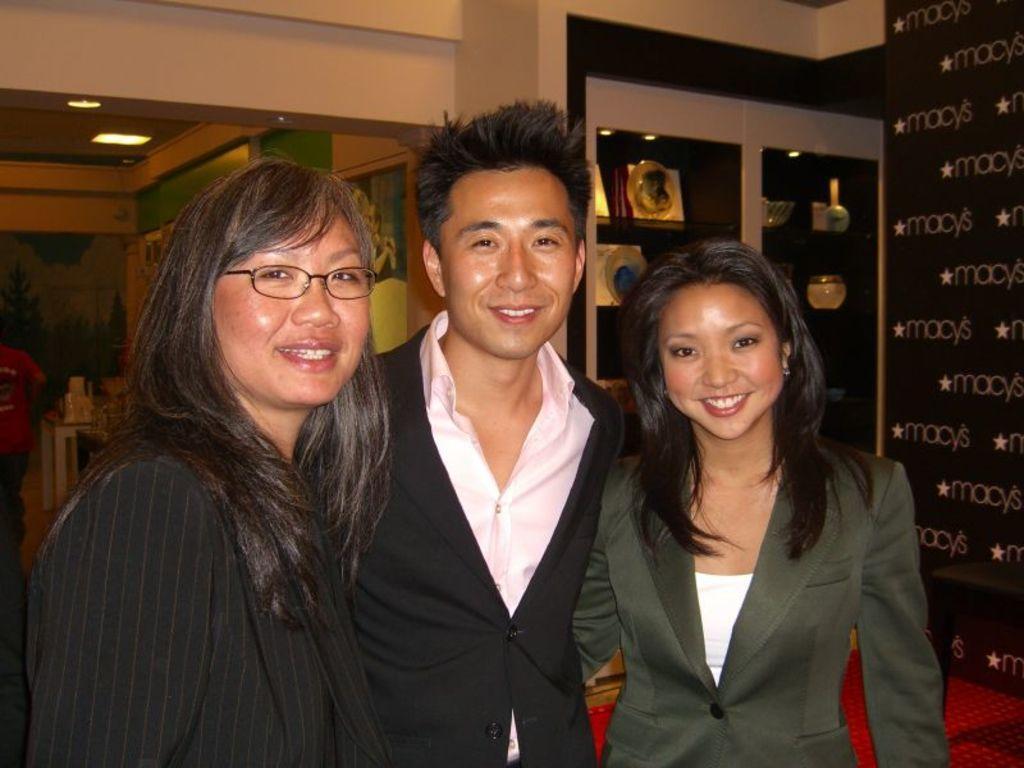Please provide a concise description of this image. In the center of the image we can see three persons are standing and they are smiling and they are in different costumes. Among them, we can see a person is wearing glasses. In the background there is a wall, banner, stool, lights, shelves with some objects, one person is standing and a few other objects. 